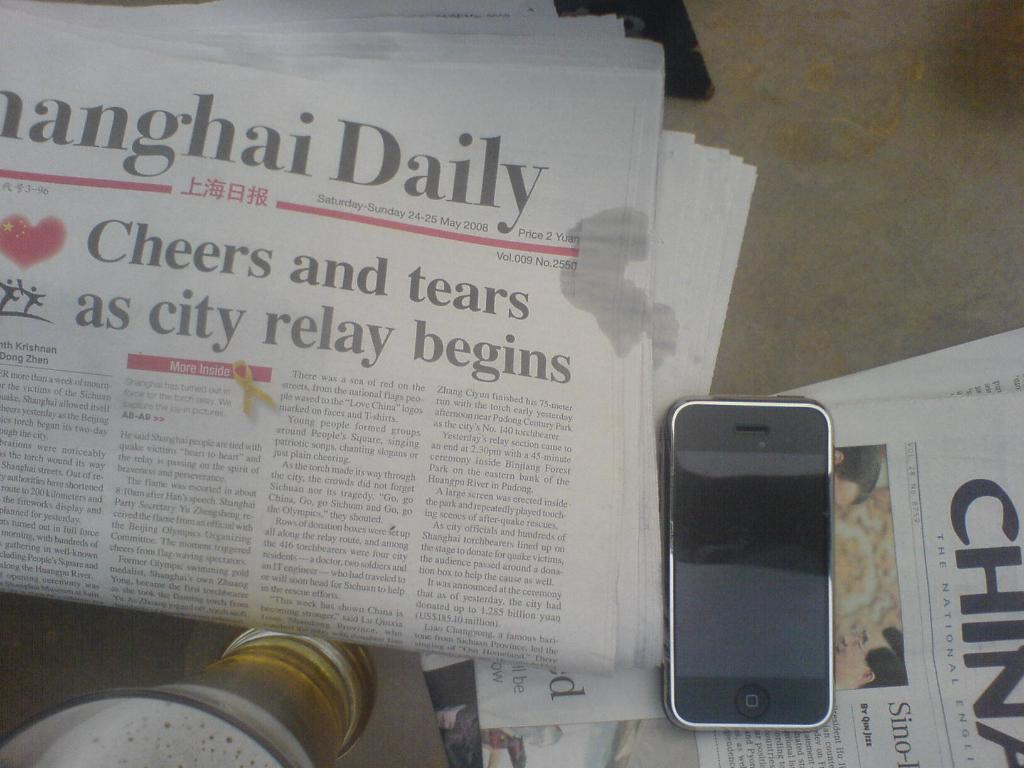<image>
Create a compact narrative representing the image presented. copy of shanghai daily newspaper next to phone and another paper 